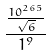Convert formula to latex. <formula><loc_0><loc_0><loc_500><loc_500>\frac { \frac { 1 0 ^ { 2 6 5 } } { \sqrt { 6 } } } { 1 ^ { 9 } }</formula> 